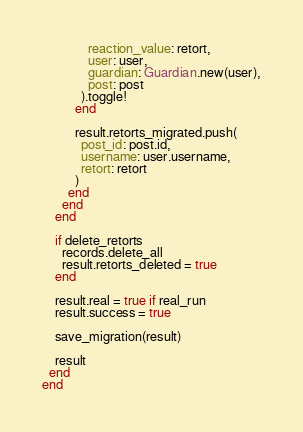Convert code to text. <code><loc_0><loc_0><loc_500><loc_500><_Ruby_>              reaction_value: retort,
              user: user,
              guardian: Guardian.new(user),
              post: post
            ).toggle!
          end
          
          result.retorts_migrated.push(
            post_id: post.id,
            username: user.username,
            retort: retort
          )
        end
      end
    end

    if delete_retorts
      records.delete_all
      result.retorts_deleted = true
    end
    
    result.real = true if real_run
    result.success = true
    
    save_migration(result)
    
    result
  end
end</code> 